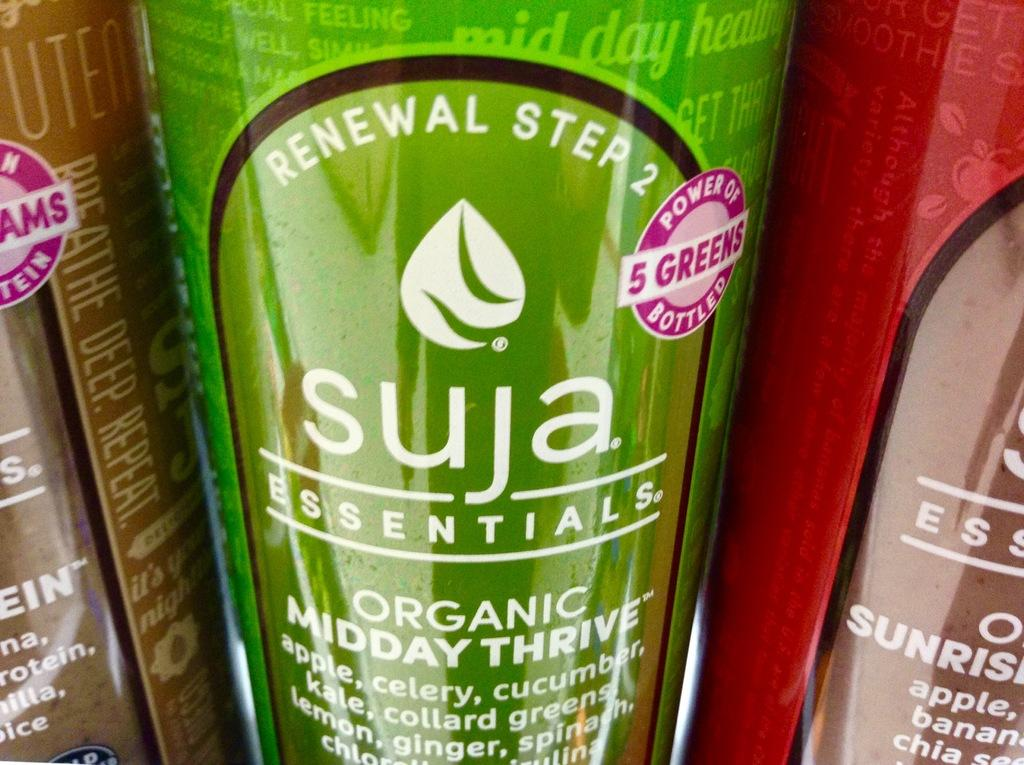<image>
Share a concise interpretation of the image provided. the organic thrive drink  displayed  and the brand name of  Suja essential brand 